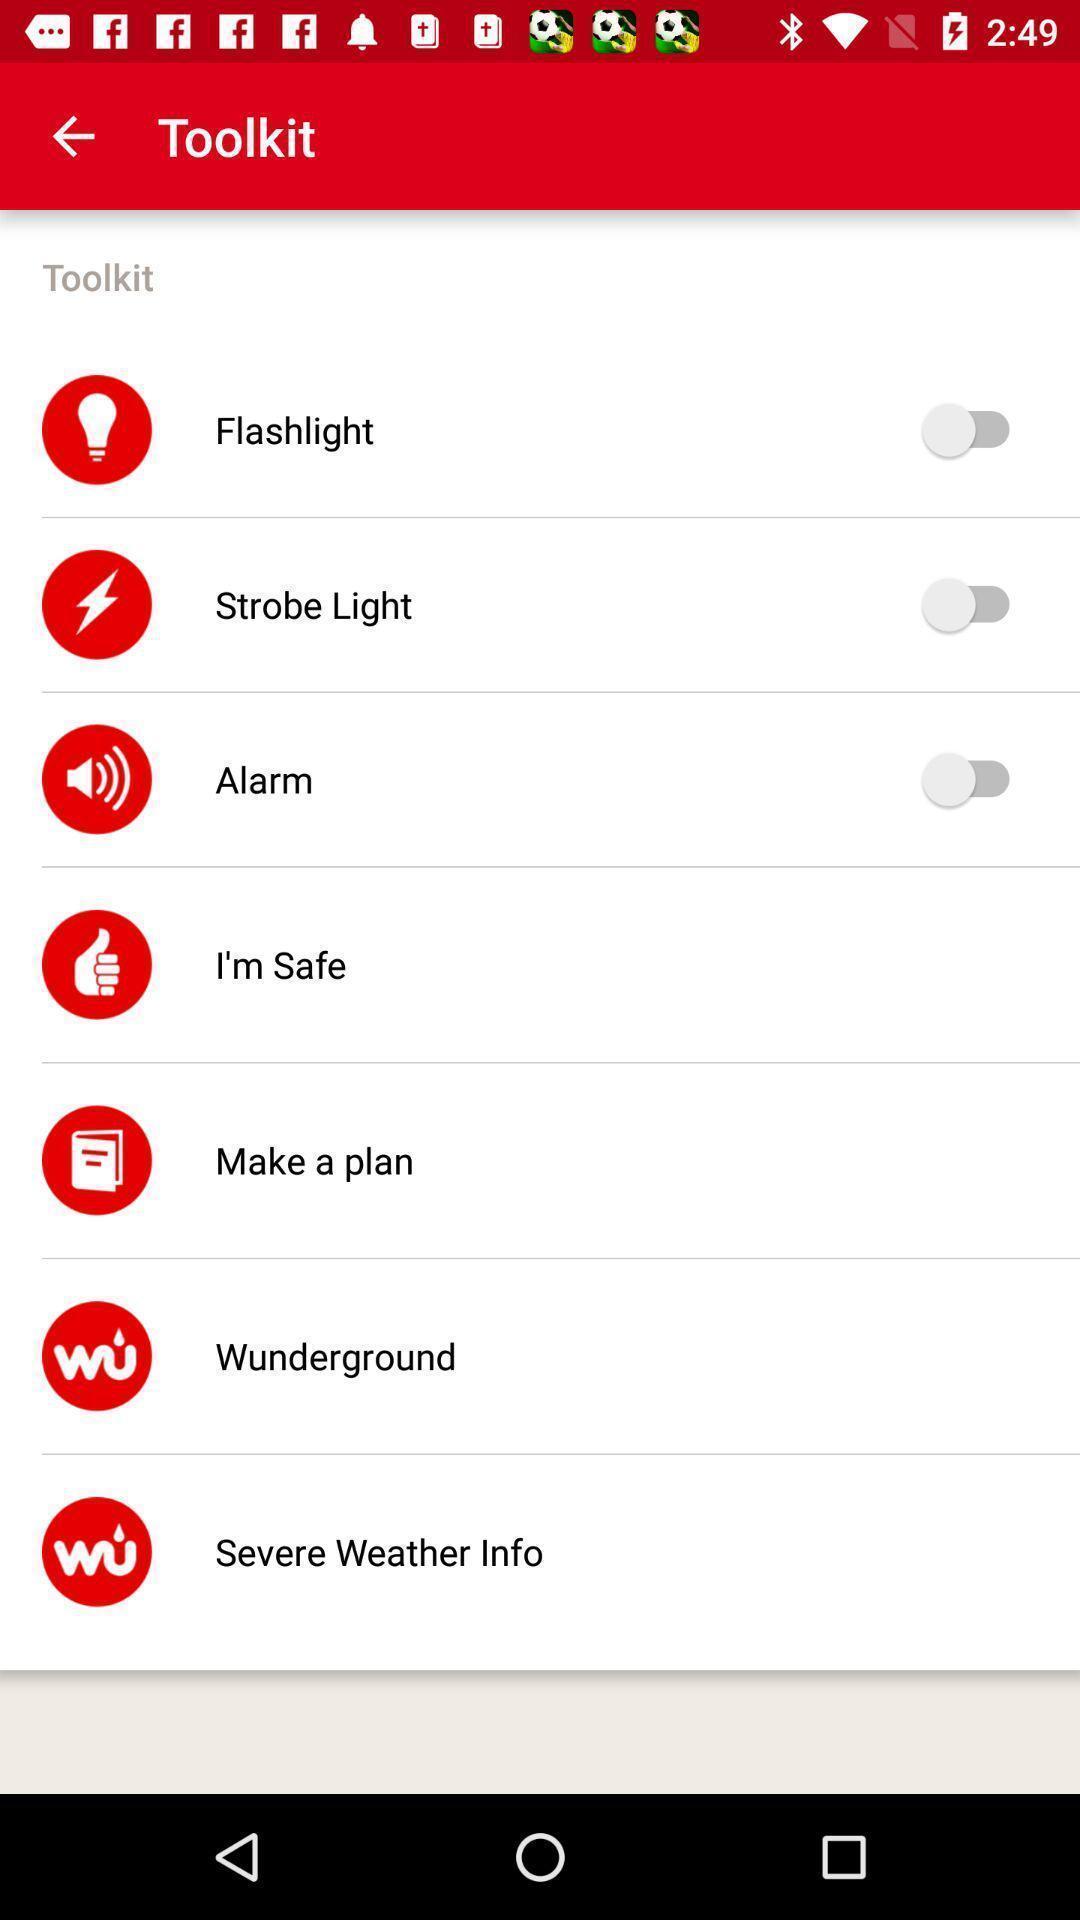Explain the elements present in this screenshot. Screen displaying list of settings. 